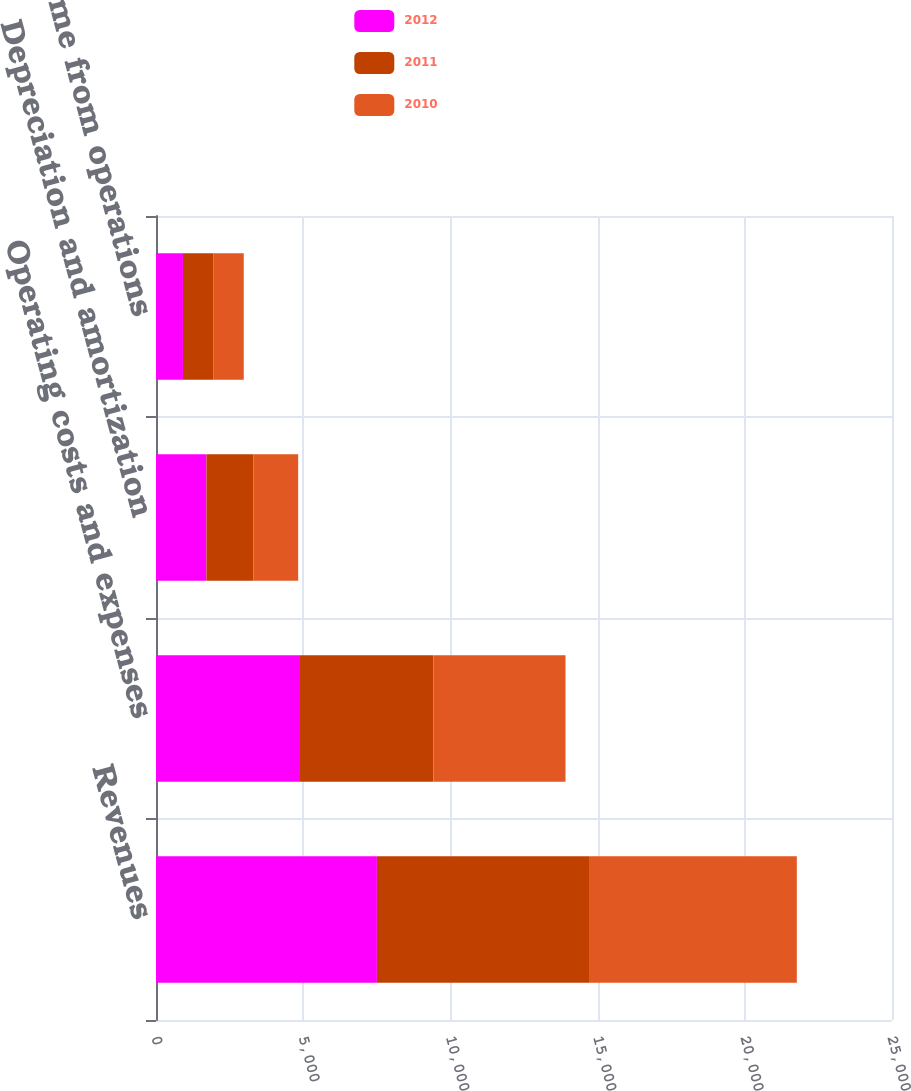Convert chart. <chart><loc_0><loc_0><loc_500><loc_500><stacked_bar_chart><ecel><fcel>Revenues<fcel>Operating costs and expenses<fcel>Depreciation and amortization<fcel>Income from operations<nl><fcel>2012<fcel>7504<fcel>4860<fcel>1713<fcel>916<nl><fcel>2011<fcel>7204<fcel>4564<fcel>1592<fcel>1041<nl><fcel>2010<fcel>7059<fcel>4486<fcel>1524<fcel>1024<nl></chart> 